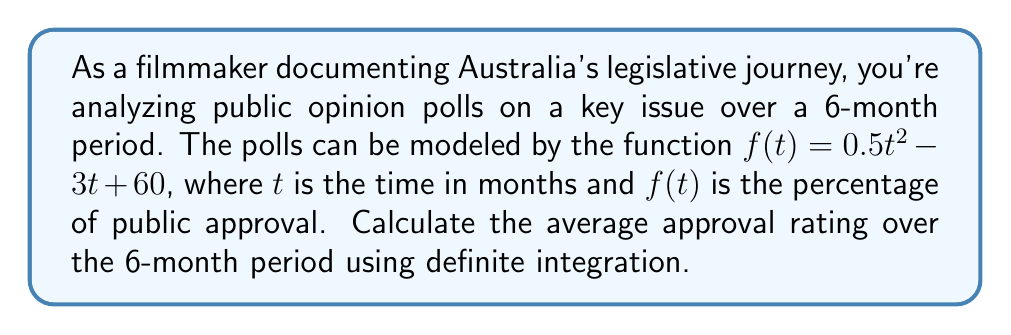Could you help me with this problem? To find the average approval rating, we need to:

1. Calculate the area under the curve from $t=0$ to $t=6$
2. Divide this area by the total time period (6 months)

Step 1: Calculate the area under the curve
We use the definite integral:

$$\int_0^6 (0.5t^2 - 3t + 60) dt$$

Integrating each term:

$$\left[\frac{0.5t^3}{3} - \frac{3t^2}{2} + 60t\right]_0^6$$

Evaluating at the bounds:

$$\left(\frac{0.5(6^3)}{3} - \frac{3(6^2)}{2} + 60(6)\right) - \left(\frac{0.5(0^3)}{3} - \frac{3(0^2)}{2} + 60(0)\right)$$

$$= (36 - 54 + 360) - (0 - 0 + 0) = 342$$

Step 2: Divide by the time period
Average approval rating = $\frac{342}{6} = 57$

Therefore, the average approval rating over the 6-month period is 57%.
Answer: 57% 